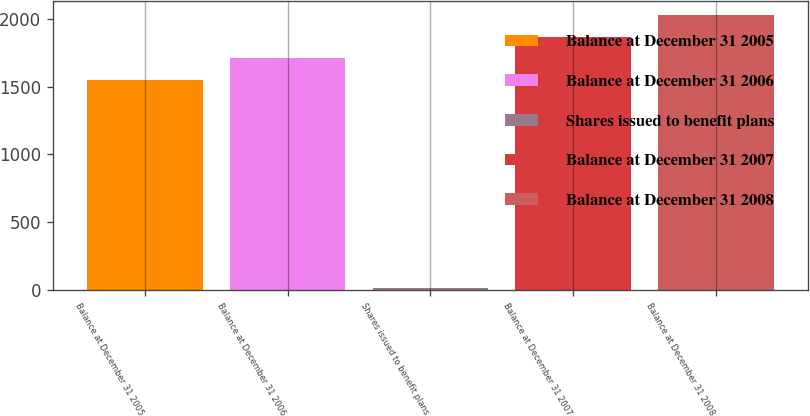Convert chart to OTSL. <chart><loc_0><loc_0><loc_500><loc_500><bar_chart><fcel>Balance at December 31 2005<fcel>Balance at December 31 2006<fcel>Shares issued to benefit plans<fcel>Balance at December 31 2007<fcel>Balance at December 31 2008<nl><fcel>1552<fcel>1711.4<fcel>15<fcel>1870.8<fcel>2030.2<nl></chart> 